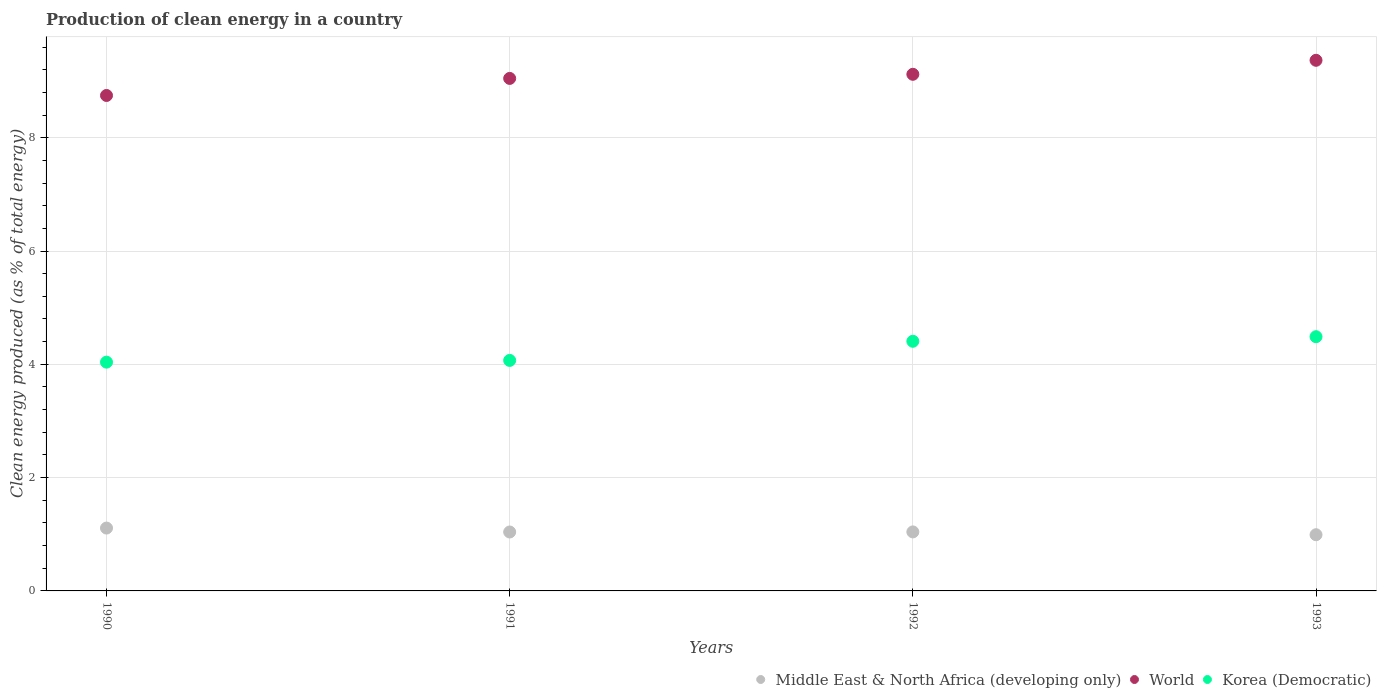Is the number of dotlines equal to the number of legend labels?
Offer a very short reply. Yes. What is the percentage of clean energy produced in Korea (Democratic) in 1991?
Your answer should be compact. 4.07. Across all years, what is the maximum percentage of clean energy produced in World?
Your answer should be compact. 9.37. Across all years, what is the minimum percentage of clean energy produced in World?
Make the answer very short. 8.75. In which year was the percentage of clean energy produced in Korea (Democratic) minimum?
Ensure brevity in your answer.  1990. What is the total percentage of clean energy produced in World in the graph?
Give a very brief answer. 36.28. What is the difference between the percentage of clean energy produced in Korea (Democratic) in 1992 and that in 1993?
Give a very brief answer. -0.08. What is the difference between the percentage of clean energy produced in Korea (Democratic) in 1992 and the percentage of clean energy produced in Middle East & North Africa (developing only) in 1990?
Offer a terse response. 3.3. What is the average percentage of clean energy produced in World per year?
Make the answer very short. 9.07. In the year 1990, what is the difference between the percentage of clean energy produced in World and percentage of clean energy produced in Middle East & North Africa (developing only)?
Your response must be concise. 7.64. What is the ratio of the percentage of clean energy produced in World in 1990 to that in 1991?
Offer a very short reply. 0.97. Is the percentage of clean energy produced in Middle East & North Africa (developing only) in 1992 less than that in 1993?
Keep it short and to the point. No. What is the difference between the highest and the second highest percentage of clean energy produced in Korea (Democratic)?
Provide a succinct answer. 0.08. What is the difference between the highest and the lowest percentage of clean energy produced in Korea (Democratic)?
Make the answer very short. 0.45. In how many years, is the percentage of clean energy produced in Korea (Democratic) greater than the average percentage of clean energy produced in Korea (Democratic) taken over all years?
Make the answer very short. 2. How many dotlines are there?
Provide a short and direct response. 3. What is the difference between two consecutive major ticks on the Y-axis?
Your answer should be compact. 2. Are the values on the major ticks of Y-axis written in scientific E-notation?
Offer a terse response. No. How many legend labels are there?
Make the answer very short. 3. What is the title of the graph?
Your answer should be very brief. Production of clean energy in a country. Does "India" appear as one of the legend labels in the graph?
Provide a succinct answer. No. What is the label or title of the Y-axis?
Provide a succinct answer. Clean energy produced (as % of total energy). What is the Clean energy produced (as % of total energy) of Middle East & North Africa (developing only) in 1990?
Ensure brevity in your answer.  1.11. What is the Clean energy produced (as % of total energy) of World in 1990?
Keep it short and to the point. 8.75. What is the Clean energy produced (as % of total energy) of Korea (Democratic) in 1990?
Give a very brief answer. 4.04. What is the Clean energy produced (as % of total energy) of Middle East & North Africa (developing only) in 1991?
Ensure brevity in your answer.  1.04. What is the Clean energy produced (as % of total energy) of World in 1991?
Keep it short and to the point. 9.05. What is the Clean energy produced (as % of total energy) in Korea (Democratic) in 1991?
Keep it short and to the point. 4.07. What is the Clean energy produced (as % of total energy) in Middle East & North Africa (developing only) in 1992?
Your answer should be very brief. 1.04. What is the Clean energy produced (as % of total energy) of World in 1992?
Keep it short and to the point. 9.12. What is the Clean energy produced (as % of total energy) of Korea (Democratic) in 1992?
Offer a terse response. 4.41. What is the Clean energy produced (as % of total energy) in Middle East & North Africa (developing only) in 1993?
Provide a succinct answer. 0.99. What is the Clean energy produced (as % of total energy) in World in 1993?
Offer a very short reply. 9.37. What is the Clean energy produced (as % of total energy) in Korea (Democratic) in 1993?
Provide a short and direct response. 4.49. Across all years, what is the maximum Clean energy produced (as % of total energy) in Middle East & North Africa (developing only)?
Ensure brevity in your answer.  1.11. Across all years, what is the maximum Clean energy produced (as % of total energy) in World?
Offer a very short reply. 9.37. Across all years, what is the maximum Clean energy produced (as % of total energy) in Korea (Democratic)?
Ensure brevity in your answer.  4.49. Across all years, what is the minimum Clean energy produced (as % of total energy) in Middle East & North Africa (developing only)?
Ensure brevity in your answer.  0.99. Across all years, what is the minimum Clean energy produced (as % of total energy) in World?
Give a very brief answer. 8.75. Across all years, what is the minimum Clean energy produced (as % of total energy) in Korea (Democratic)?
Your answer should be very brief. 4.04. What is the total Clean energy produced (as % of total energy) of Middle East & North Africa (developing only) in the graph?
Provide a succinct answer. 4.18. What is the total Clean energy produced (as % of total energy) in World in the graph?
Offer a very short reply. 36.28. What is the total Clean energy produced (as % of total energy) of Korea (Democratic) in the graph?
Make the answer very short. 17. What is the difference between the Clean energy produced (as % of total energy) of Middle East & North Africa (developing only) in 1990 and that in 1991?
Keep it short and to the point. 0.07. What is the difference between the Clean energy produced (as % of total energy) in World in 1990 and that in 1991?
Your answer should be compact. -0.3. What is the difference between the Clean energy produced (as % of total energy) of Korea (Democratic) in 1990 and that in 1991?
Your answer should be very brief. -0.03. What is the difference between the Clean energy produced (as % of total energy) in Middle East & North Africa (developing only) in 1990 and that in 1992?
Offer a terse response. 0.07. What is the difference between the Clean energy produced (as % of total energy) of World in 1990 and that in 1992?
Ensure brevity in your answer.  -0.37. What is the difference between the Clean energy produced (as % of total energy) in Korea (Democratic) in 1990 and that in 1992?
Offer a terse response. -0.37. What is the difference between the Clean energy produced (as % of total energy) of Middle East & North Africa (developing only) in 1990 and that in 1993?
Your answer should be compact. 0.12. What is the difference between the Clean energy produced (as % of total energy) of World in 1990 and that in 1993?
Provide a short and direct response. -0.62. What is the difference between the Clean energy produced (as % of total energy) of Korea (Democratic) in 1990 and that in 1993?
Give a very brief answer. -0.45. What is the difference between the Clean energy produced (as % of total energy) of Middle East & North Africa (developing only) in 1991 and that in 1992?
Keep it short and to the point. -0. What is the difference between the Clean energy produced (as % of total energy) of World in 1991 and that in 1992?
Provide a succinct answer. -0.07. What is the difference between the Clean energy produced (as % of total energy) of Korea (Democratic) in 1991 and that in 1992?
Keep it short and to the point. -0.34. What is the difference between the Clean energy produced (as % of total energy) in Middle East & North Africa (developing only) in 1991 and that in 1993?
Provide a succinct answer. 0.05. What is the difference between the Clean energy produced (as % of total energy) in World in 1991 and that in 1993?
Keep it short and to the point. -0.32. What is the difference between the Clean energy produced (as % of total energy) in Korea (Democratic) in 1991 and that in 1993?
Your answer should be very brief. -0.42. What is the difference between the Clean energy produced (as % of total energy) in Middle East & North Africa (developing only) in 1992 and that in 1993?
Your response must be concise. 0.05. What is the difference between the Clean energy produced (as % of total energy) in World in 1992 and that in 1993?
Offer a terse response. -0.25. What is the difference between the Clean energy produced (as % of total energy) of Korea (Democratic) in 1992 and that in 1993?
Offer a terse response. -0.08. What is the difference between the Clean energy produced (as % of total energy) in Middle East & North Africa (developing only) in 1990 and the Clean energy produced (as % of total energy) in World in 1991?
Your answer should be very brief. -7.94. What is the difference between the Clean energy produced (as % of total energy) of Middle East & North Africa (developing only) in 1990 and the Clean energy produced (as % of total energy) of Korea (Democratic) in 1991?
Provide a succinct answer. -2.96. What is the difference between the Clean energy produced (as % of total energy) of World in 1990 and the Clean energy produced (as % of total energy) of Korea (Democratic) in 1991?
Provide a short and direct response. 4.68. What is the difference between the Clean energy produced (as % of total energy) of Middle East & North Africa (developing only) in 1990 and the Clean energy produced (as % of total energy) of World in 1992?
Your answer should be compact. -8.01. What is the difference between the Clean energy produced (as % of total energy) in Middle East & North Africa (developing only) in 1990 and the Clean energy produced (as % of total energy) in Korea (Democratic) in 1992?
Provide a short and direct response. -3.3. What is the difference between the Clean energy produced (as % of total energy) of World in 1990 and the Clean energy produced (as % of total energy) of Korea (Democratic) in 1992?
Provide a short and direct response. 4.34. What is the difference between the Clean energy produced (as % of total energy) in Middle East & North Africa (developing only) in 1990 and the Clean energy produced (as % of total energy) in World in 1993?
Keep it short and to the point. -8.26. What is the difference between the Clean energy produced (as % of total energy) in Middle East & North Africa (developing only) in 1990 and the Clean energy produced (as % of total energy) in Korea (Democratic) in 1993?
Offer a terse response. -3.38. What is the difference between the Clean energy produced (as % of total energy) of World in 1990 and the Clean energy produced (as % of total energy) of Korea (Democratic) in 1993?
Provide a short and direct response. 4.26. What is the difference between the Clean energy produced (as % of total energy) in Middle East & North Africa (developing only) in 1991 and the Clean energy produced (as % of total energy) in World in 1992?
Offer a very short reply. -8.08. What is the difference between the Clean energy produced (as % of total energy) in Middle East & North Africa (developing only) in 1991 and the Clean energy produced (as % of total energy) in Korea (Democratic) in 1992?
Ensure brevity in your answer.  -3.37. What is the difference between the Clean energy produced (as % of total energy) of World in 1991 and the Clean energy produced (as % of total energy) of Korea (Democratic) in 1992?
Your response must be concise. 4.64. What is the difference between the Clean energy produced (as % of total energy) of Middle East & North Africa (developing only) in 1991 and the Clean energy produced (as % of total energy) of World in 1993?
Your answer should be compact. -8.33. What is the difference between the Clean energy produced (as % of total energy) in Middle East & North Africa (developing only) in 1991 and the Clean energy produced (as % of total energy) in Korea (Democratic) in 1993?
Make the answer very short. -3.45. What is the difference between the Clean energy produced (as % of total energy) of World in 1991 and the Clean energy produced (as % of total energy) of Korea (Democratic) in 1993?
Offer a very short reply. 4.56. What is the difference between the Clean energy produced (as % of total energy) in Middle East & North Africa (developing only) in 1992 and the Clean energy produced (as % of total energy) in World in 1993?
Your response must be concise. -8.32. What is the difference between the Clean energy produced (as % of total energy) of Middle East & North Africa (developing only) in 1992 and the Clean energy produced (as % of total energy) of Korea (Democratic) in 1993?
Provide a succinct answer. -3.45. What is the difference between the Clean energy produced (as % of total energy) in World in 1992 and the Clean energy produced (as % of total energy) in Korea (Democratic) in 1993?
Offer a terse response. 4.63. What is the average Clean energy produced (as % of total energy) of Middle East & North Africa (developing only) per year?
Keep it short and to the point. 1.05. What is the average Clean energy produced (as % of total energy) of World per year?
Ensure brevity in your answer.  9.07. What is the average Clean energy produced (as % of total energy) in Korea (Democratic) per year?
Your answer should be compact. 4.25. In the year 1990, what is the difference between the Clean energy produced (as % of total energy) of Middle East & North Africa (developing only) and Clean energy produced (as % of total energy) of World?
Provide a short and direct response. -7.64. In the year 1990, what is the difference between the Clean energy produced (as % of total energy) of Middle East & North Africa (developing only) and Clean energy produced (as % of total energy) of Korea (Democratic)?
Ensure brevity in your answer.  -2.93. In the year 1990, what is the difference between the Clean energy produced (as % of total energy) of World and Clean energy produced (as % of total energy) of Korea (Democratic)?
Your answer should be compact. 4.71. In the year 1991, what is the difference between the Clean energy produced (as % of total energy) in Middle East & North Africa (developing only) and Clean energy produced (as % of total energy) in World?
Offer a very short reply. -8.01. In the year 1991, what is the difference between the Clean energy produced (as % of total energy) of Middle East & North Africa (developing only) and Clean energy produced (as % of total energy) of Korea (Democratic)?
Your answer should be very brief. -3.03. In the year 1991, what is the difference between the Clean energy produced (as % of total energy) of World and Clean energy produced (as % of total energy) of Korea (Democratic)?
Your answer should be very brief. 4.98. In the year 1992, what is the difference between the Clean energy produced (as % of total energy) of Middle East & North Africa (developing only) and Clean energy produced (as % of total energy) of World?
Offer a terse response. -8.08. In the year 1992, what is the difference between the Clean energy produced (as % of total energy) in Middle East & North Africa (developing only) and Clean energy produced (as % of total energy) in Korea (Democratic)?
Provide a succinct answer. -3.37. In the year 1992, what is the difference between the Clean energy produced (as % of total energy) of World and Clean energy produced (as % of total energy) of Korea (Democratic)?
Your response must be concise. 4.71. In the year 1993, what is the difference between the Clean energy produced (as % of total energy) in Middle East & North Africa (developing only) and Clean energy produced (as % of total energy) in World?
Offer a very short reply. -8.37. In the year 1993, what is the difference between the Clean energy produced (as % of total energy) in Middle East & North Africa (developing only) and Clean energy produced (as % of total energy) in Korea (Democratic)?
Ensure brevity in your answer.  -3.5. In the year 1993, what is the difference between the Clean energy produced (as % of total energy) of World and Clean energy produced (as % of total energy) of Korea (Democratic)?
Offer a terse response. 4.88. What is the ratio of the Clean energy produced (as % of total energy) in Middle East & North Africa (developing only) in 1990 to that in 1991?
Provide a succinct answer. 1.07. What is the ratio of the Clean energy produced (as % of total energy) in World in 1990 to that in 1991?
Provide a succinct answer. 0.97. What is the ratio of the Clean energy produced (as % of total energy) in Korea (Democratic) in 1990 to that in 1991?
Offer a terse response. 0.99. What is the ratio of the Clean energy produced (as % of total energy) in Middle East & North Africa (developing only) in 1990 to that in 1992?
Provide a short and direct response. 1.07. What is the ratio of the Clean energy produced (as % of total energy) of World in 1990 to that in 1992?
Ensure brevity in your answer.  0.96. What is the ratio of the Clean energy produced (as % of total energy) of Korea (Democratic) in 1990 to that in 1992?
Provide a succinct answer. 0.92. What is the ratio of the Clean energy produced (as % of total energy) in Middle East & North Africa (developing only) in 1990 to that in 1993?
Keep it short and to the point. 1.12. What is the ratio of the Clean energy produced (as % of total energy) in World in 1990 to that in 1993?
Offer a very short reply. 0.93. What is the ratio of the Clean energy produced (as % of total energy) in Korea (Democratic) in 1990 to that in 1993?
Provide a succinct answer. 0.9. What is the ratio of the Clean energy produced (as % of total energy) in World in 1991 to that in 1992?
Provide a succinct answer. 0.99. What is the ratio of the Clean energy produced (as % of total energy) of Korea (Democratic) in 1991 to that in 1992?
Make the answer very short. 0.92. What is the ratio of the Clean energy produced (as % of total energy) in Middle East & North Africa (developing only) in 1991 to that in 1993?
Ensure brevity in your answer.  1.05. What is the ratio of the Clean energy produced (as % of total energy) in World in 1991 to that in 1993?
Offer a terse response. 0.97. What is the ratio of the Clean energy produced (as % of total energy) of Korea (Democratic) in 1991 to that in 1993?
Provide a short and direct response. 0.91. What is the ratio of the Clean energy produced (as % of total energy) in Middle East & North Africa (developing only) in 1992 to that in 1993?
Ensure brevity in your answer.  1.05. What is the ratio of the Clean energy produced (as % of total energy) in World in 1992 to that in 1993?
Ensure brevity in your answer.  0.97. What is the difference between the highest and the second highest Clean energy produced (as % of total energy) in Middle East & North Africa (developing only)?
Ensure brevity in your answer.  0.07. What is the difference between the highest and the second highest Clean energy produced (as % of total energy) in World?
Your answer should be compact. 0.25. What is the difference between the highest and the second highest Clean energy produced (as % of total energy) in Korea (Democratic)?
Provide a succinct answer. 0.08. What is the difference between the highest and the lowest Clean energy produced (as % of total energy) of Middle East & North Africa (developing only)?
Offer a very short reply. 0.12. What is the difference between the highest and the lowest Clean energy produced (as % of total energy) of World?
Provide a succinct answer. 0.62. What is the difference between the highest and the lowest Clean energy produced (as % of total energy) in Korea (Democratic)?
Offer a terse response. 0.45. 